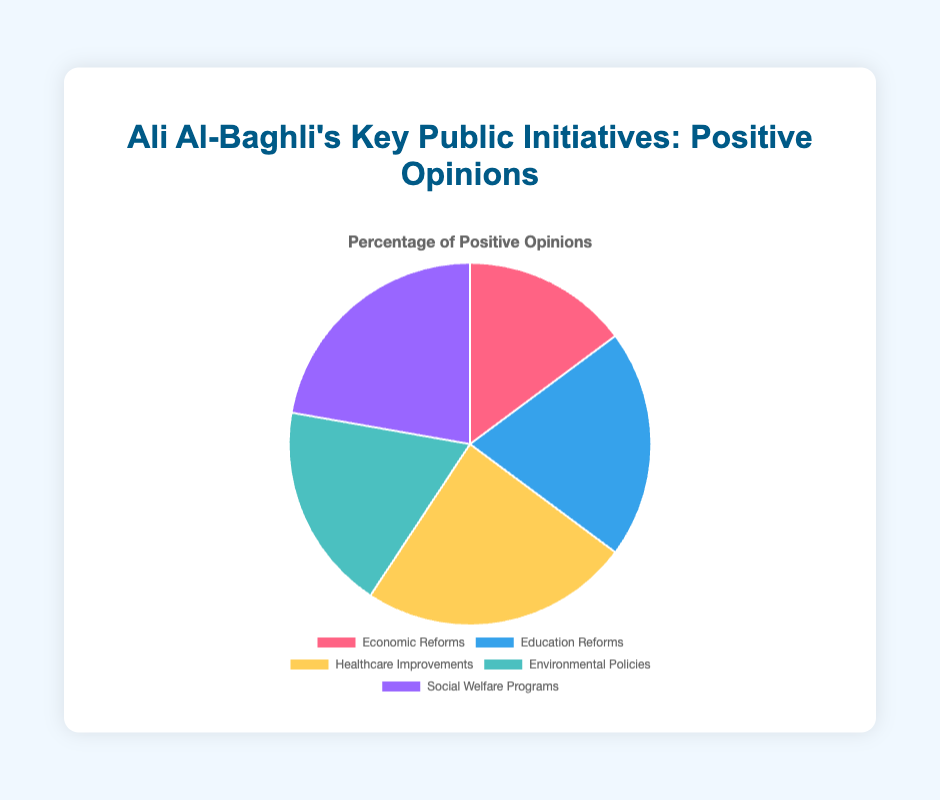What is the positive opinion percentage for the Healthcare Improvements initiative? The percentage of positive opinions for the Healthcare Improvements initiative is directly visible from the figure. It is displayed as a slice of the pie chart labeled "Healthcare Improvements".
Answer: 65% Which initiative received the highest percentage of positive opinions? By comparing the sizes and labels of the pie slices, we identify the initiative with the largest slice representing positive opinions. The Healthcare Improvements initiative has the highest percentage at 65%.
Answer: Healthcare Improvements Which two initiatives combined received a total of 110% positive opinions? To find the sum of the positive opinions for two initiatives that equal 110%, we check the individual percentages and sum them. Adding Social Welfare Programs (60%) and Education Reforms (50%) yields 110%.
Answer: Social Welfare Programs and Environmental Policies What is the difference in positive opinion percentages between the Economic Reforms and Education Reforms initiatives? By subtracting the percentage of positive opinions for Economic Reforms (40%) from that for Education Reforms (55%), we get the difference.
Answer: 15% How does the percentage of positive opinions for Social Welfare Programs compare to that for Environmental Policies? To compare the percentages, we check the values for Social Welfare Programs (60%) and Environmental Policies (50%). Social Welfare Programs have a higher positive opinion percentage.
Answer: Social Welfare Programs is higher What is the total percentage of positive opinions for all initiatives combined? Adding the positive opinions for all initiatives: Economic Reforms (40%), Education Reforms (55%), Healthcare Improvements (65%), Environmental Policies (50%), and Social Welfare Programs (60%) gives 270%.
Answer: 270% Which initiative has the highest neutral opinion percentage? By identifying the initiative with the highest neutral opinion from the figure data, Healthcare Improvements has the highest at 30%.
Answer: Economic Reforms If you equally distribute the positive opinions among all five initiatives, what percentage does each initiative get? Dividing the sum of positive opinions (270%) by the five initiatives, each gets 54%.
Answer: 54% What is the median percentage of positive opinions among the initiatives? Ordering the positive opinion percentages (40%, 50%, 55%, 60%, 65%) and identifying the middle value gives the median.
Answer: 55% How many more percentage points of positive opinions does Healthcare Improvements have compared to Environmental Policies and Social Welfare Programs? Taking Healthcare Improvements (65%) and comparing it to Environmental Policies (50%) and Social Welfare Programs (60%): 65 - 50 = 15, and 65 - 60 = 5.
Answer: 15 and 5 